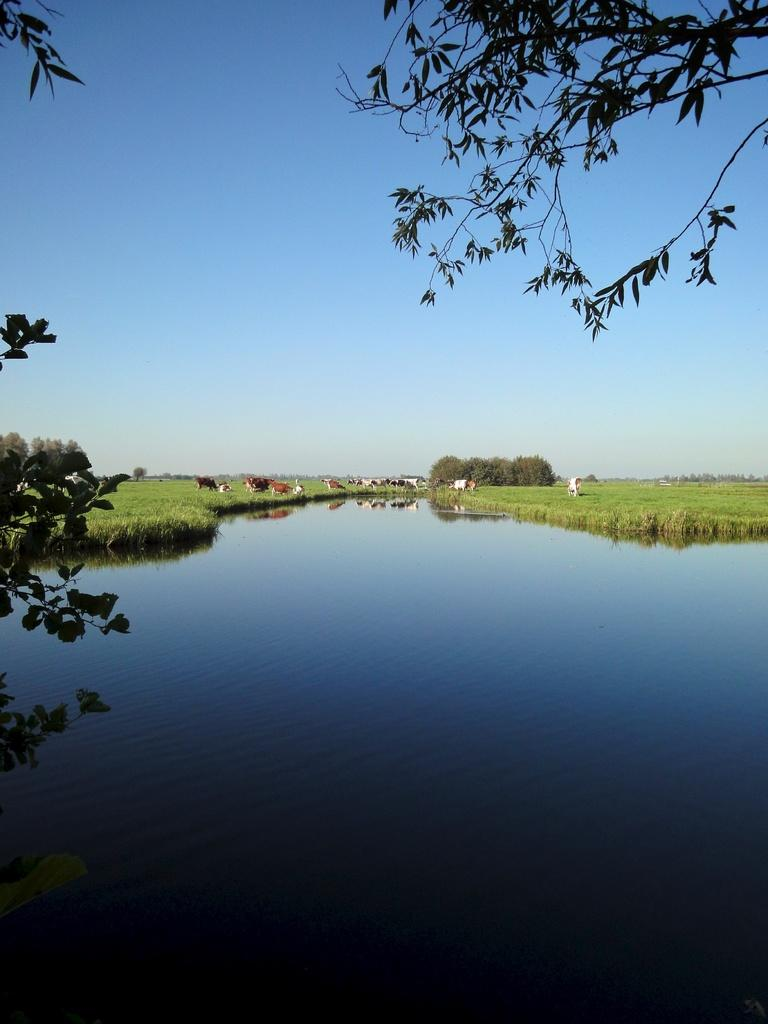What type of animals can be seen in the image? There are cows in the image. Where are the cows located? The cows are in the grass. What else can be seen in the image besides the cows? There is water, trees, and the sky visible in the image. What type of acoustics can be heard in the image? There is no sound present in the image, so it is not possible to determine the acoustics. 